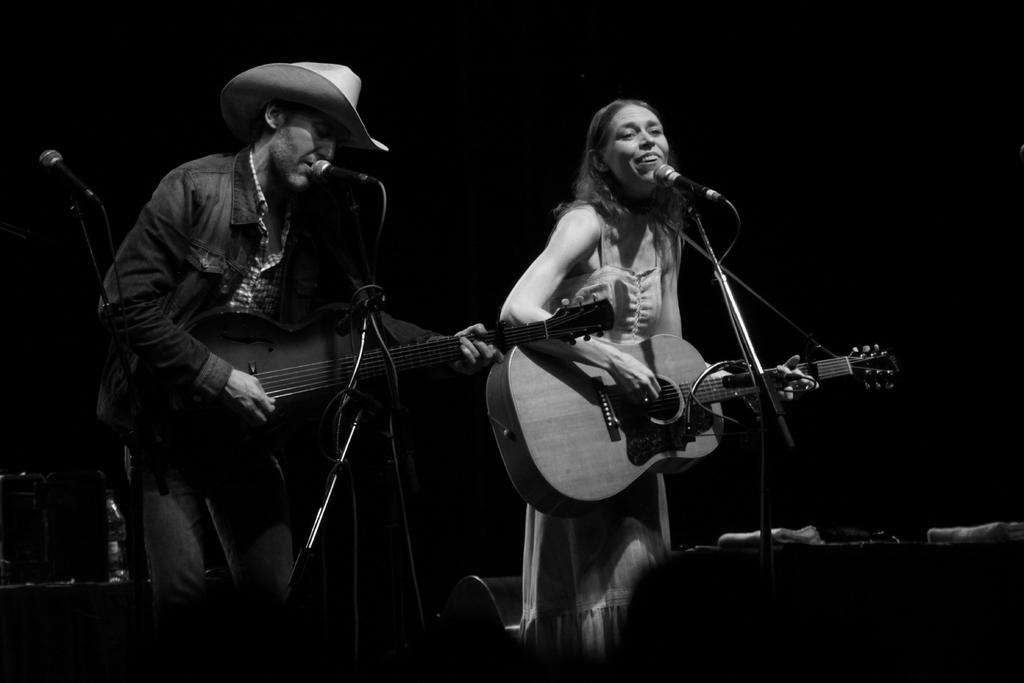What is the woman in the image doing? The woman is standing and playing a guitar in the image. Is there any equipment near the woman? Yes, the woman is near a microphone. What is the man in the image doing? The man is standing and playing a guitar in the image. What is the man doing with the microphone? The man is singing into the microphone. What type of cough does the dad have in the image? There is no dad or cough present in the image. Is the door open or closed in the image? There is no door present in the image. 